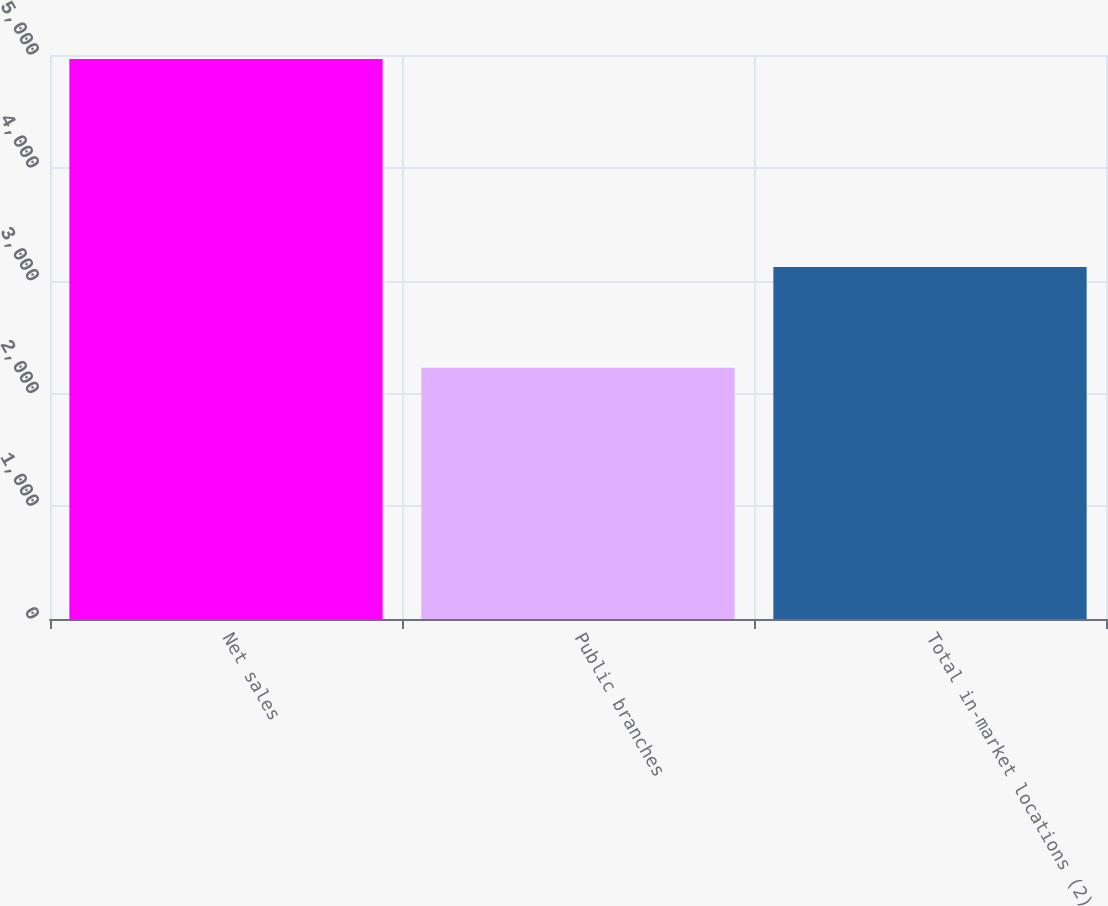<chart> <loc_0><loc_0><loc_500><loc_500><bar_chart><fcel>Net sales<fcel>Public branches<fcel>Total in-market locations (2)<nl><fcel>4965.1<fcel>2227<fcel>3121<nl></chart> 